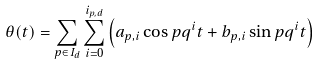<formula> <loc_0><loc_0><loc_500><loc_500>\theta ( t ) = \sum _ { p \in I _ { d } } \sum _ { i = 0 } ^ { i _ { p , d } } \left ( a _ { p , i } \cos p q ^ { i } t + b _ { p , i } \sin p q ^ { i } t \right )</formula> 